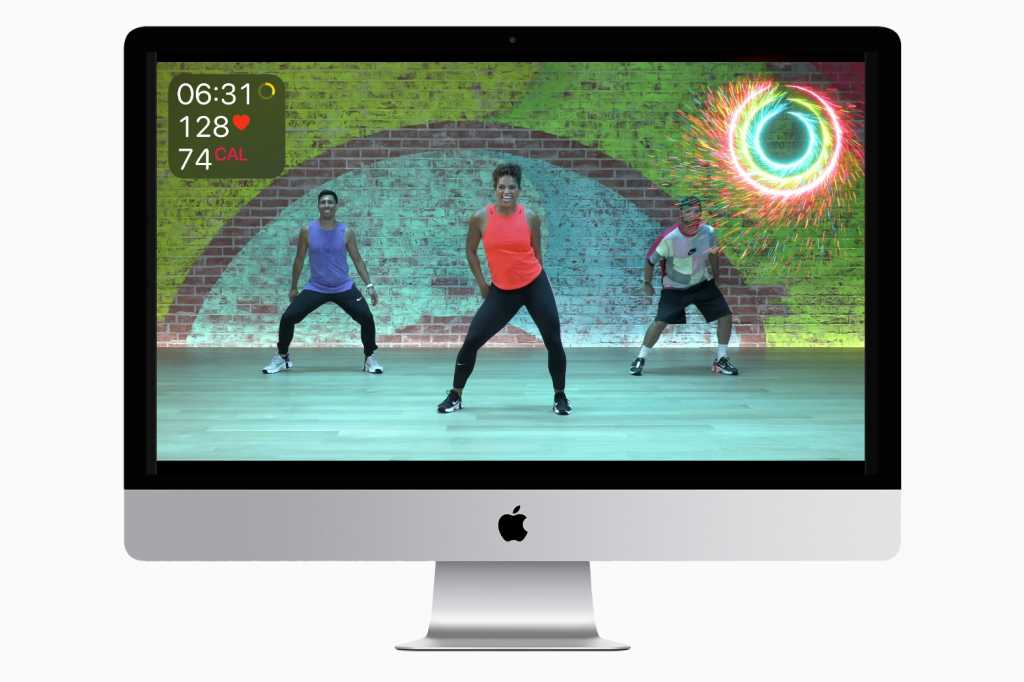Considering the detailed information presented on the computer screen, what can be inferred about the purpose of the software or application being used by the individuals in the image? The purpose of the software or application is primarily focused on fitness training and workout guidance. This is indicated by the visible metrics such as the timer, heart rate, and calories burned, which are common indicators of physical activity tracking. Additionally, the presence of a graphical representation of an eye might signify a monitoring or tracking feature that could be designed to motivate users or provide insights into their workout performance. The individuals in the image are dressed in workout attire and actively participating in a fitness routine, further supporting the conclusion that the software is used for fitness purposes. The colorful and dynamic interface suggests an effort to make the experience engaging and visually appealing to users. 